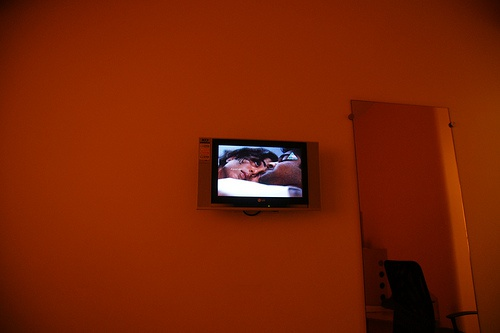Describe the objects in this image and their specific colors. I can see tv in black, maroon, white, and brown tones, chair in maroon and black tones, people in black, white, maroon, and purple tones, and people in black, brown, maroon, and lightpink tones in this image. 